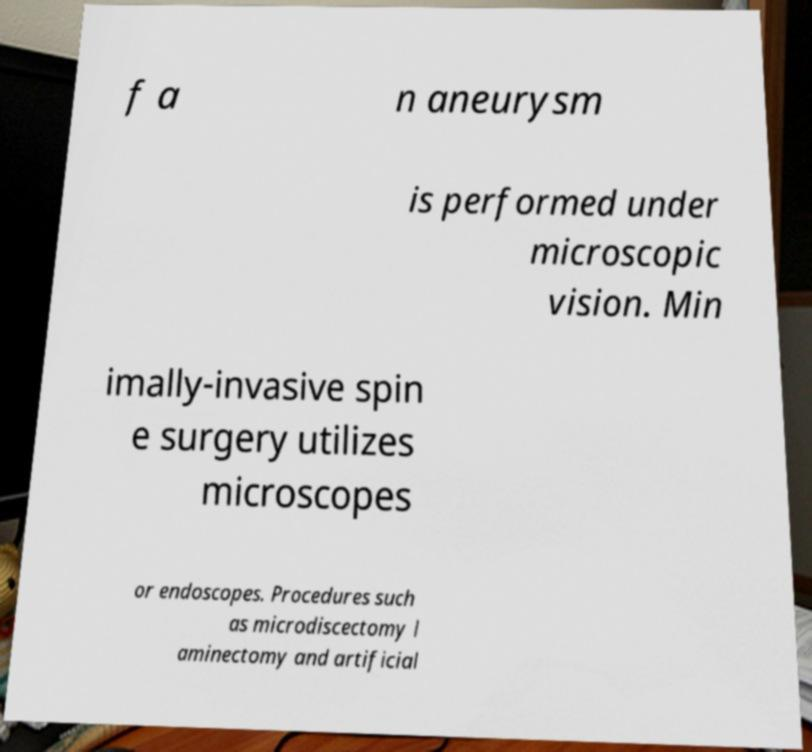Can you read and provide the text displayed in the image?This photo seems to have some interesting text. Can you extract and type it out for me? f a n aneurysm is performed under microscopic vision. Min imally-invasive spin e surgery utilizes microscopes or endoscopes. Procedures such as microdiscectomy l aminectomy and artificial 